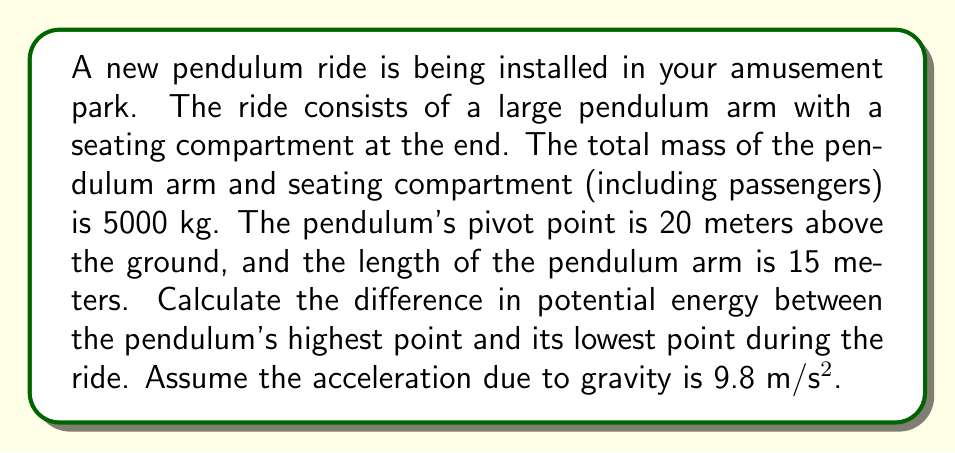Teach me how to tackle this problem. To solve this problem, we'll use the formula for gravitational potential energy:

$$ PE = mgh $$

Where:
$m$ = mass of the object
$g$ = acceleration due to gravity
$h$ = height above a reference point

Let's break this down step-by-step:

1) First, we need to determine the heights of the highest and lowest points of the pendulum:

   Highest point: $20 + 15 = 35$ meters above the ground
   Lowest point: $20 - 15 = 5$ meters above the ground

2) Now, we can calculate the potential energy at the highest point:

   $$ PE_{high} = 5000 \times 9.8 \times 35 = 1,715,000 \text{ J} $$

3) And the potential energy at the lowest point:

   $$ PE_{low} = 5000 \times 9.8 \times 5 = 245,000 \text{ J} $$

4) The difference in potential energy is:

   $$ \Delta PE = PE_{high} - PE_{low} = 1,715,000 - 245,000 = 1,470,000 \text{ J} $$

This difference represents the maximum amount of energy that can be converted to kinetic energy during the ride, which is crucial for safety considerations.
Answer: The difference in potential energy between the pendulum's highest and lowest points is 1,470,000 J or 1.47 MJ. 